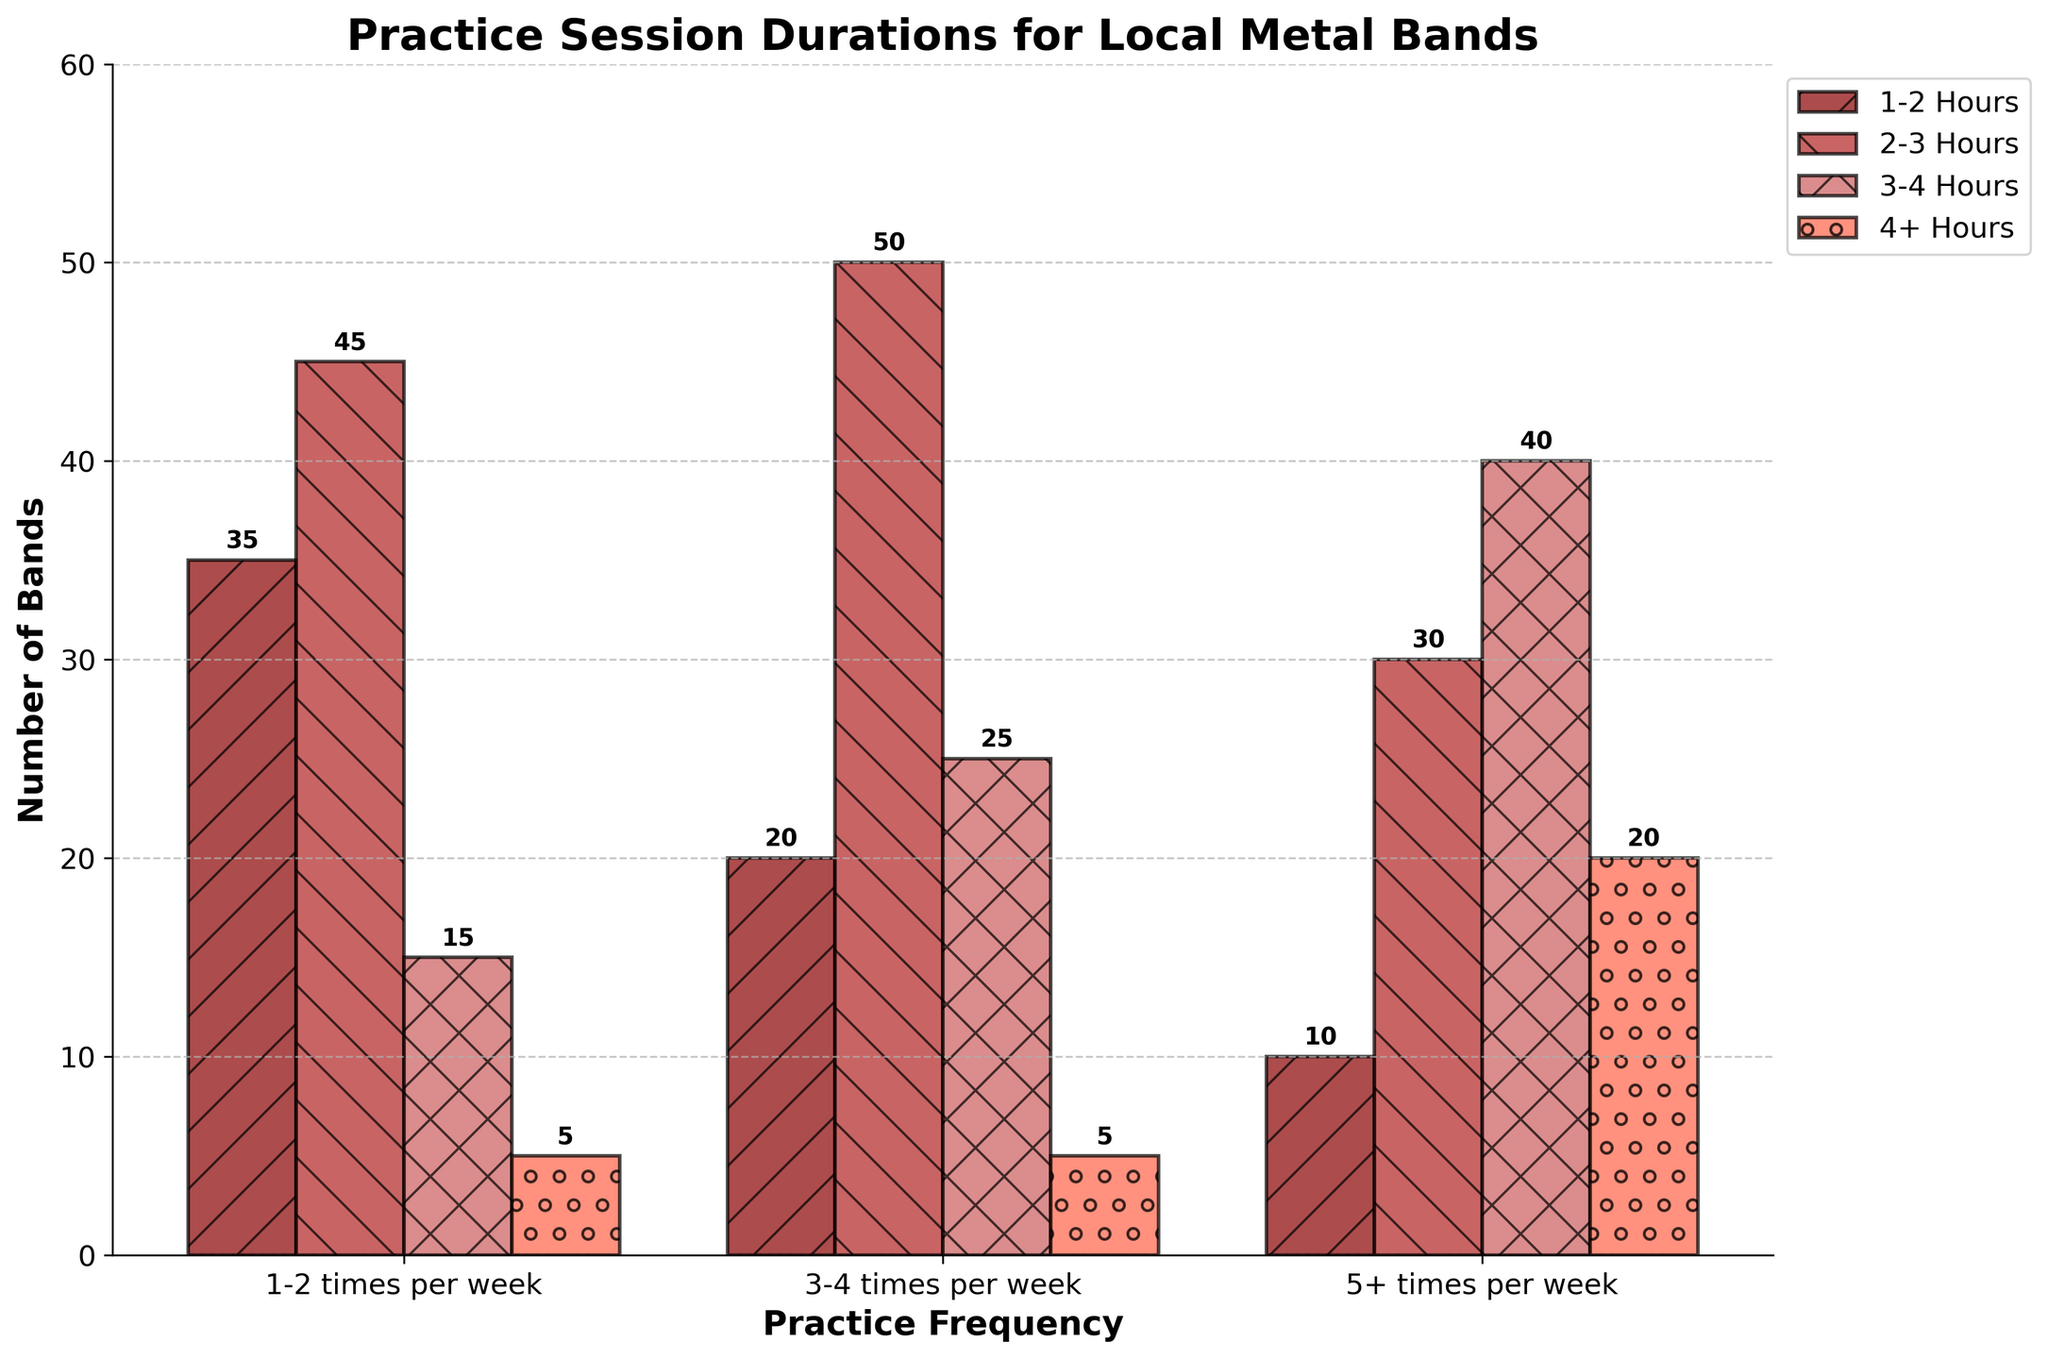What's the most common practice session duration for bands practicing 3-4 times per week? Look at the values for bands practicing 3-4 times per week and identify the duration with the highest value. The highest value is for 2-3 hours with 50 bands.
Answer: 2-3 hours How many bands practice a total of more than 30 hours per week? Identify the groups that practice more than 30 hours per week (3-4 hours duration X 5+ times per week = 40, and 4+ hours duration X 5+ times per week = 20). Sum their counts: 40 + 20 = 60.
Answer: 60 Which practice frequency has the least number of bands practicing 1-2 hours? Compare the number of bands practicing 1-2 hours across all practice frequencies. The least number is 10 from the 5+ times per week group.
Answer: 5+ times per week What is the combined number of bands that practice for 2-3 hours across all frequencies? Sum the number of bands practicing for 2-3 hours across all frequencies: 45 (1-2 times per week) + 50 (3-4 times per week) + 30 (5+ times per week). The total is 125.
Answer: 125 Which practice session duration shows the biggest difference in band numbers between 1-2 times and 5+ times per week? Calculate the differences for each duration: 1-2 hours: 35-10=25, 2-3 hours: 45-30=15, 3-4 hours: 15-40=-25, 4+ hours: 5-20=-15. The biggest difference is for 1-2 hours with a difference of 25.
Answer: 1-2 hours For bands practicing 4+ hours, how does the number of bands change from practicing 1-2 times per week to 5+ times per week? Compare the numbers: 5 (1-2 times per week) and 20 (5+ times per week). Calculate the change: 20 - 5 = 15.
Answer: Increase by 15 Which color represents the 1-2 hours practice duration? Identify the color assigned to the 1-2 hours bar across all practice frequencies. The color is dark red.
Answer: Dark red What's the second most common practice session duration for bands practicing 5+ times per week? Look at the values for bands practicing 5+ times per week and identify the second highest duration value. The second highest value is 30 bands for 2-3 hours.
Answer: 2-3 hours 